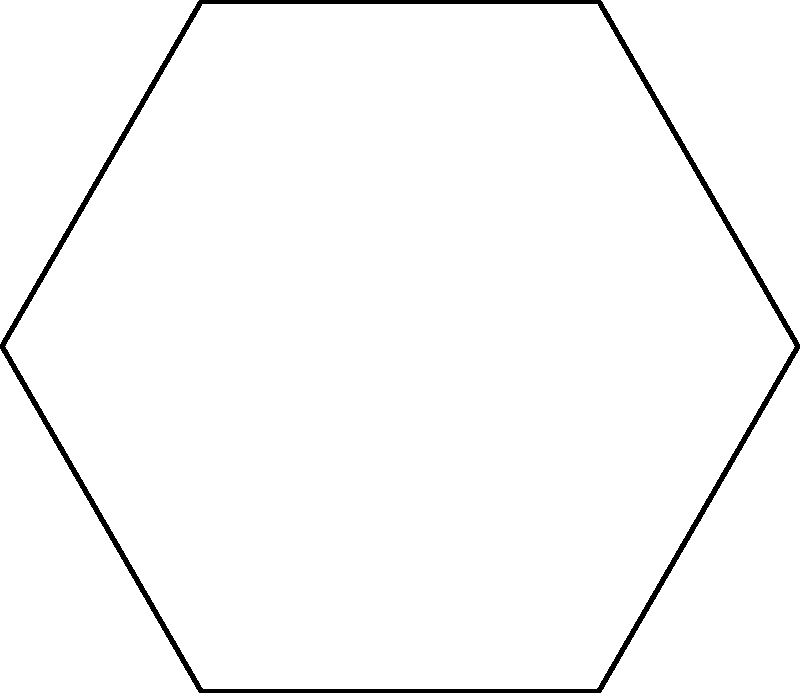In nature, honeycomb cells form perfect hexagons. If a single hexagonal cell in a honeycomb has a side length of 5 mm, what is the total perimeter of the cell? Express your answer in terms of π. To find the perimeter of a hexagonal honeycomb cell, we can follow these steps:

1. Recall that a hexagon has 6 equal sides.

2. The formula for the perimeter of a regular polygon is:
   $$P = ns$$
   where $n$ is the number of sides and $s$ is the length of each side.

3. In this case:
   $n = 6$ (hexagon)
   $s = 5$ mm (given in the question)

4. Substituting these values into the formula:
   $$P = 6 \times 5 \text{ mm} = 30 \text{ mm}$$

5. However, the question asks for the answer in terms of π. We need to convert this to an expression involving π.

6. Recall that the perimeter of a regular hexagon can also be expressed as:
   $$P = 4r\sqrt{3}$$
   where $r$ is the radius of the circumscribed circle.

7. Setting our two perimeter expressions equal:
   $$30 = 4r\sqrt{3}$$

8. Solving for $r$:
   $$r = \frac{30}{4\sqrt{3}} = \frac{5\sqrt{3}}{2}$$

9. Now, we can express this in terms of π. The radius of a circle circumscribing a regular hexagon is equal to the side length of the hexagon. Therefore:
   $$5 = \frac{2\pi r}{6}$$

10. Solving for $r$:
    $$r = \frac{15}{\pi}$$

11. Substituting this back into the perimeter formula:
    $$P = 4r\sqrt{3} = 4 \cdot \frac{15}{\pi} \cdot \sqrt{3} = \frac{60\sqrt{3}}{\pi}$$

Thus, the perimeter of the hexagonal cell, expressed in terms of π, is $\frac{60\sqrt{3}}{\pi}$ mm.
Answer: $\frac{60\sqrt{3}}{\pi}$ mm 